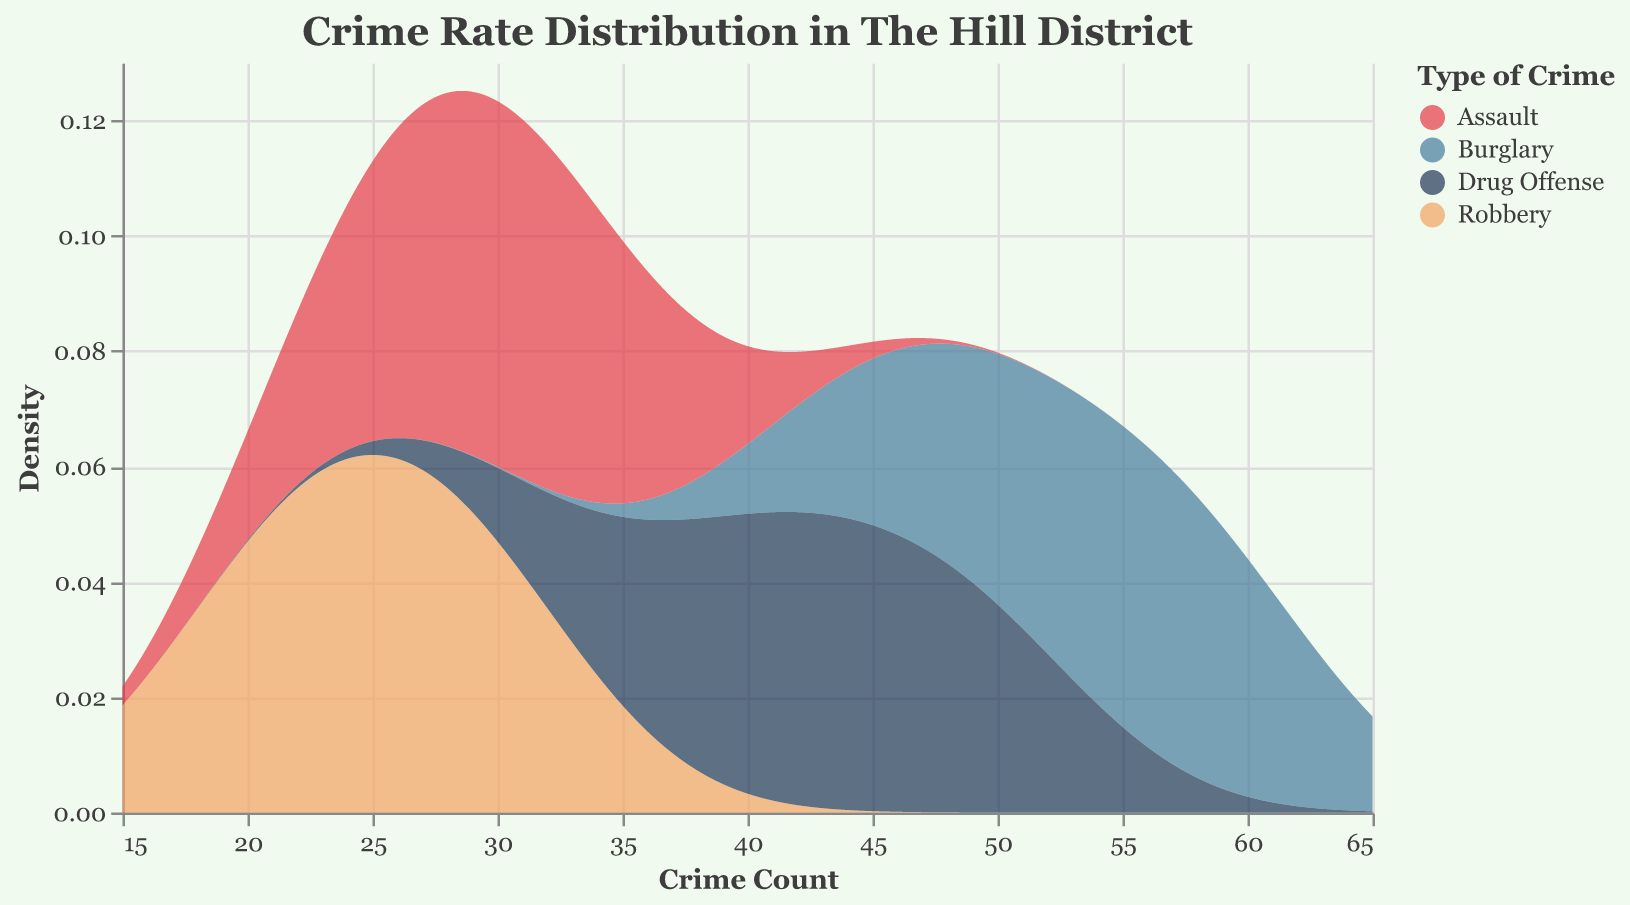What is the title of the figure? The title of the figure is located at the top and gives an overview of the data being visualized.
Answer: Crime Rate Distribution in The Hill District What are the axes labels? The x-axis represents the "Crime Count," and the y-axis represents "Density."
Answer: Crime Count and Density What are the types of crimes listed in the color legend? The legend indicates the categories of crimes each color represents by displaying their names.
Answer: Burglary, Assault, Robbery, Drug Offense Which crime type shows the highest density at the lower crime count ranges? By looking at the density curves, the "Burglary" category (represented by the red color) stands out prominently at lower crime counts.
Answer: Burglary Which crime type has a relatively consistent density across a wider range of crime counts? The "Drug Offense" category (represented by the orange color) has a more evenly spread density curve across a range of crime counts.
Answer: Drug Offense How does the density of Assault crimes compare to Robbery crimes at a crime count of 25? By examining the figure at a crime count of 25, you can see that the density curve for Assault is higher than that of Robbery.
Answer: Assault has a higher density than Robbery Which crime type had the highest count in 2021? Looking at the data provided, the CrimeType "Burglary" had the highest count in 2021 with a count of 60.
Answer: Burglary Which year had the highest total crime count for all crime types combined? Summing the counts for each year: 2018 (45+30+20+35), 2019 (50+25+22+40), 2020 (55+27+25+42), 2021 (60+32+30+50), 2022 (57+35+28+47), we find 2021 has the highest sum (172).
Answer: 2021 Which crime type has the most spread out density curve? Observing the curves, the density curve for "Drug Offense" (orange) covers a wider crime count range compared to others.
Answer: Drug Offense What has been the trend in Burglary counts from 2018 to 2022? By looking at the data for Burglary counts over the years: 45 (2018), 50 (2019), 55 (2020), 60 (2021), and 57 (2022), we see a general increasing trend up to 2021, then a slight decrease in 2022.
Answer: Increasing trend with a slight decrease in 2022 